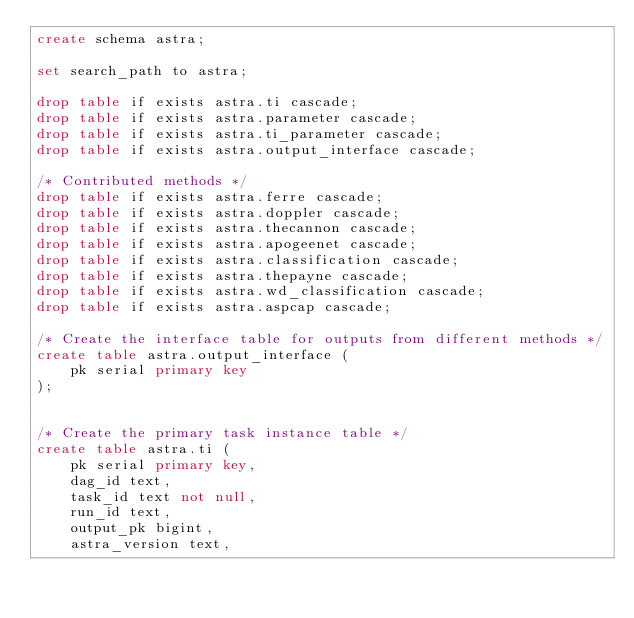<code> <loc_0><loc_0><loc_500><loc_500><_SQL_>create schema astra;

set search_path to astra;

drop table if exists astra.ti cascade;
drop table if exists astra.parameter cascade;
drop table if exists astra.ti_parameter cascade;
drop table if exists astra.output_interface cascade;

/* Contributed methods */
drop table if exists astra.ferre cascade;
drop table if exists astra.doppler cascade;
drop table if exists astra.thecannon cascade;
drop table if exists astra.apogeenet cascade;
drop table if exists astra.classification cascade;
drop table if exists astra.thepayne cascade;
drop table if exists astra.wd_classification cascade;
drop table if exists astra.aspcap cascade;

/* Create the interface table for outputs from different methods */
create table astra.output_interface (
    pk serial primary key
);


/* Create the primary task instance table */
create table astra.ti (
    pk serial primary key,
    dag_id text,
    task_id text not null,
    run_id text,
    output_pk bigint,
    astra_version text,</code> 